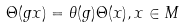<formula> <loc_0><loc_0><loc_500><loc_500>\Theta ( g x ) = \theta ( g ) \Theta ( x ) , x \in M</formula> 